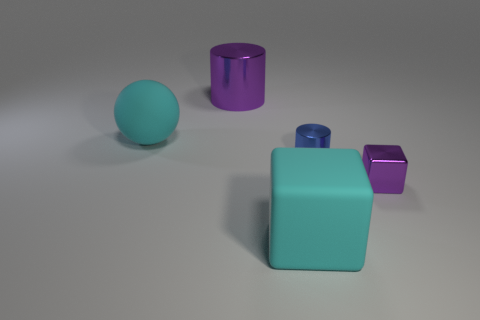Add 2 cylinders. How many objects exist? 7 Subtract all spheres. How many objects are left? 4 Add 4 blue shiny cylinders. How many blue shiny cylinders are left? 5 Add 4 large yellow spheres. How many large yellow spheres exist? 4 Subtract 0 brown balls. How many objects are left? 5 Subtract all tiny purple metal cubes. Subtract all big cyan cubes. How many objects are left? 3 